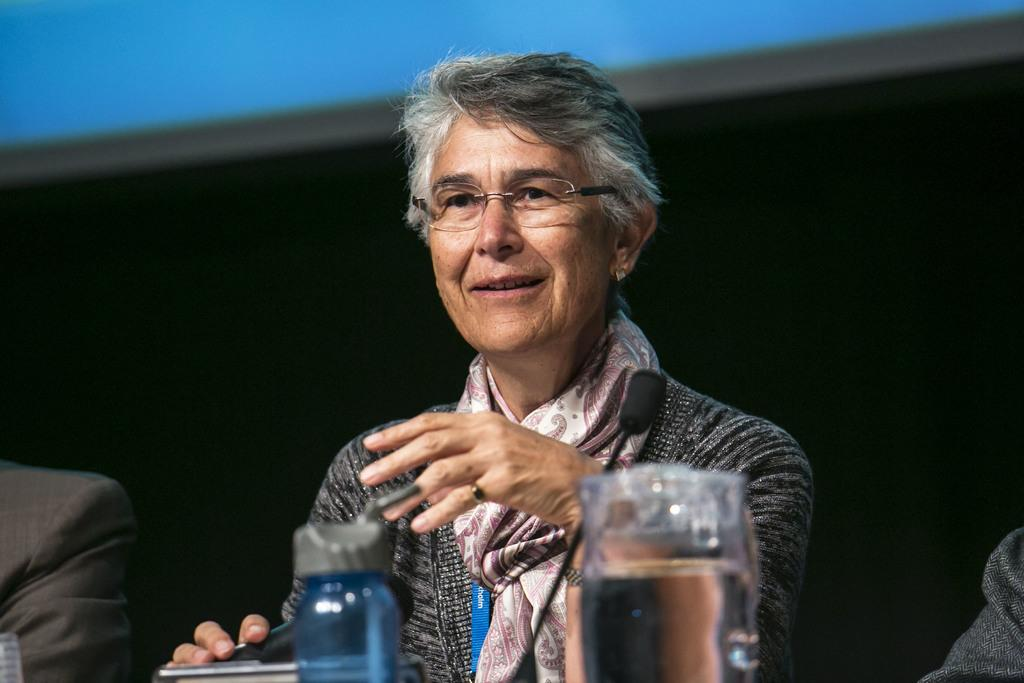What is the woman in the image doing? The woman is sitting in the image. What can be seen beside the woman? There is a person's hand beside the woman. What is in front of the woman? There is a microphone (mic), a bottle, and a glass of water in front of the woman. What is the color of the background in the image? The background of the image is dark. Can you see the moon in the image? No, the moon is not present in the image. How many houses are visible in the image? There are no houses visible in the image. 